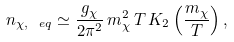Convert formula to latex. <formula><loc_0><loc_0><loc_500><loc_500>n _ { \chi , \ e q } \simeq \frac { g _ { \chi } } { 2 \pi ^ { 2 } } \, m _ { \chi } ^ { 2 } \, T \, K _ { 2 } \left ( \frac { m _ { \chi } } { T } \right ) ,</formula> 